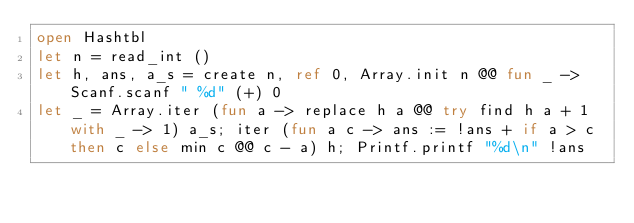Convert code to text. <code><loc_0><loc_0><loc_500><loc_500><_OCaml_>open Hashtbl
let n = read_int ()
let h, ans, a_s = create n, ref 0, Array.init n @@ fun _ -> Scanf.scanf " %d" (+) 0
let _ = Array.iter (fun a -> replace h a @@ try find h a + 1 with _ -> 1) a_s; iter (fun a c -> ans := !ans + if a > c then c else min c @@ c - a) h; Printf.printf "%d\n" !ans</code> 